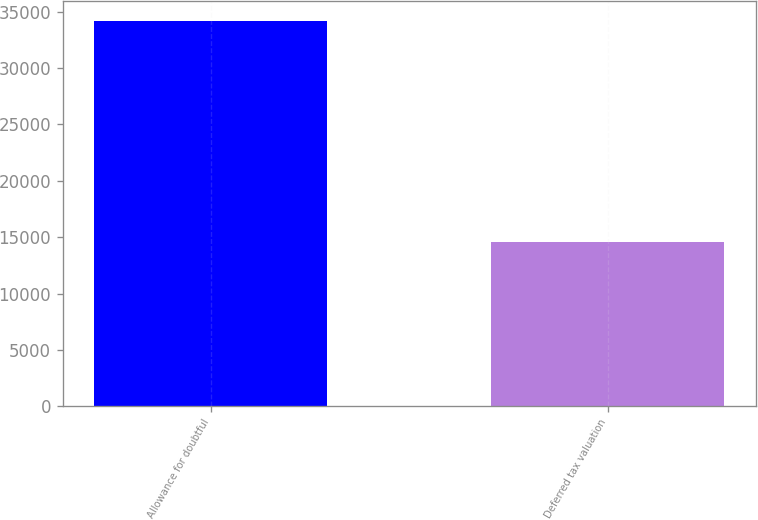<chart> <loc_0><loc_0><loc_500><loc_500><bar_chart><fcel>Allowance for doubtful<fcel>Deferred tax valuation<nl><fcel>34217<fcel>14578<nl></chart> 